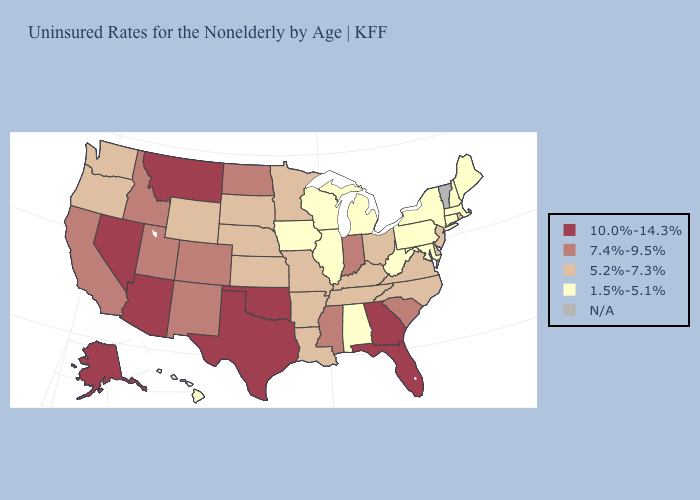Among the states that border Texas , does Arkansas have the lowest value?
Give a very brief answer. Yes. Which states hav the highest value in the West?
Answer briefly. Alaska, Arizona, Montana, Nevada. Does Indiana have the highest value in the USA?
Keep it brief. No. What is the value of Kansas?
Concise answer only. 5.2%-7.3%. Name the states that have a value in the range 1.5%-5.1%?
Answer briefly. Alabama, Connecticut, Hawaii, Illinois, Iowa, Maine, Maryland, Massachusetts, Michigan, New Hampshire, New York, Pennsylvania, West Virginia, Wisconsin. What is the value of New Mexico?
Quick response, please. 7.4%-9.5%. Does Arizona have the highest value in the USA?
Quick response, please. Yes. What is the lowest value in states that border Arkansas?
Answer briefly. 5.2%-7.3%. How many symbols are there in the legend?
Short answer required. 5. Among the states that border New Mexico , which have the lowest value?
Be succinct. Colorado, Utah. What is the value of Mississippi?
Keep it brief. 7.4%-9.5%. Among the states that border Michigan , does Indiana have the highest value?
Write a very short answer. Yes. Name the states that have a value in the range 5.2%-7.3%?
Be succinct. Arkansas, Delaware, Kansas, Kentucky, Louisiana, Minnesota, Missouri, Nebraska, New Jersey, North Carolina, Ohio, Oregon, Rhode Island, South Dakota, Tennessee, Virginia, Washington, Wyoming. 